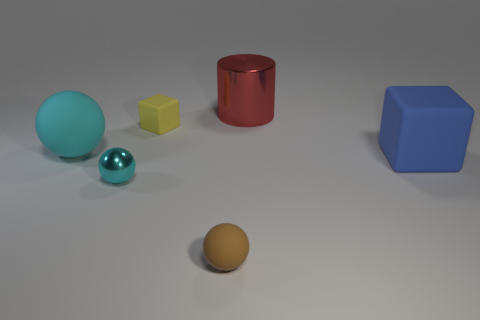How many geometric shapes can you identify in the image and can you name them? Certainly! I can identify four distinct geometric shapes in the image. There is a large blue cube on the right, a yellow cuboid (rectangular prism) towards the center, a small brown sphere at the front, and a shiny red cylinder. Additionally, there's a turquoise glossy sphere, although it's not quite a perfect geometrical shape due to its slight distortions. 